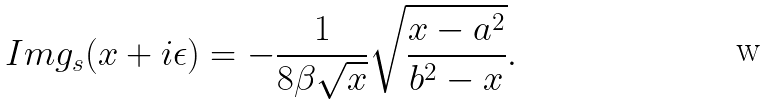Convert formula to latex. <formula><loc_0><loc_0><loc_500><loc_500>I m g _ { s } ( x + i \epsilon ) = - \frac { 1 } { 8 \beta \sqrt { x } } \sqrt { \frac { x - a ^ { 2 } } { b ^ { 2 } - x } } .</formula> 